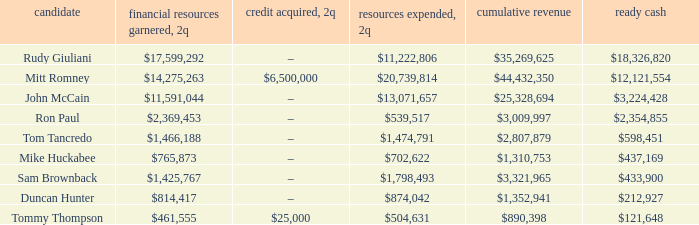Specify the financial outlay for 2q involving john mccain's candidacy. $13,071,657. 